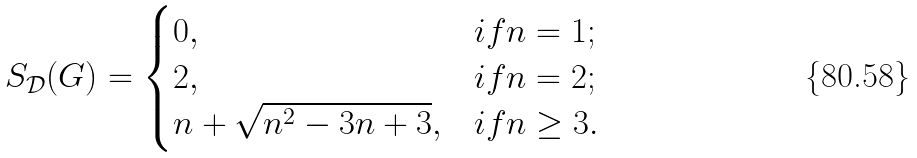<formula> <loc_0><loc_0><loc_500><loc_500>S _ { \mathcal { D } } ( G ) = \begin{cases} 0 , & i f n = 1 ; \\ 2 , & i f n = 2 ; \\ n + \sqrt { n ^ { 2 } - 3 n + 3 } , & i f n \geq 3 . \end{cases}</formula> 